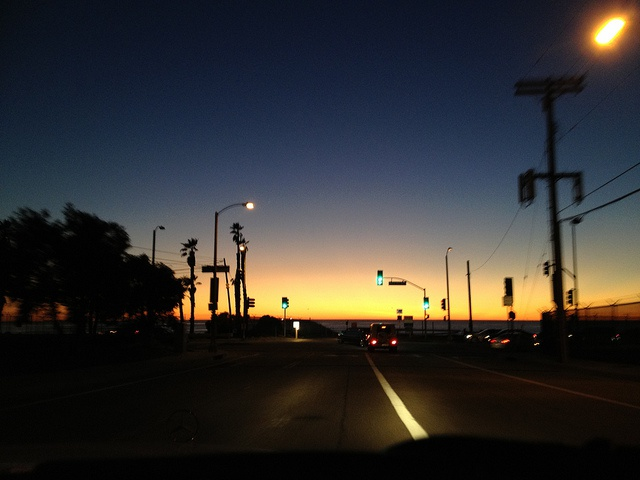Describe the objects in this image and their specific colors. I can see car in black, maroon, brown, and red tones, car in black, maroon, brown, and white tones, car in black, maroon, gray, and brown tones, traffic light in black and darkblue tones, and car in black, teal, maroon, and gray tones in this image. 